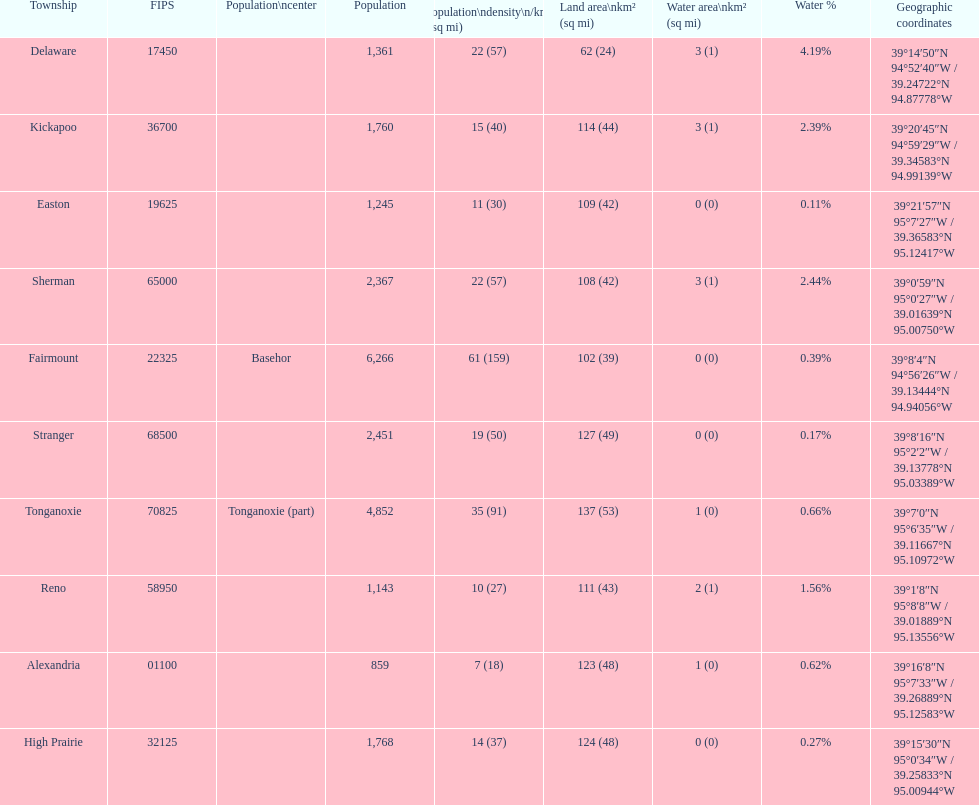What township has the most land area? Tonganoxie. 